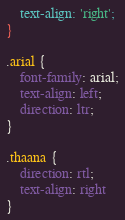<code> <loc_0><loc_0><loc_500><loc_500><_CSS_>    text-align: 'right';
}

.arial {
    font-family: arial;
    text-align: left;
    direction: ltr;
}

.thaana {
    direction: rtl;
    text-align: right
}</code> 